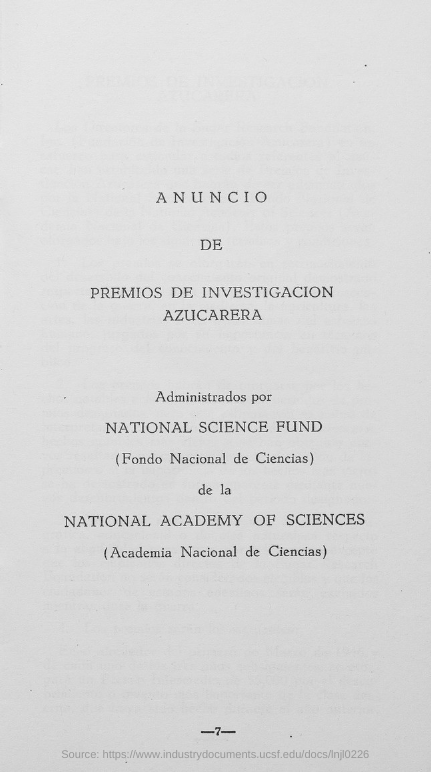What is the Page Number?
Give a very brief answer. -7-. 